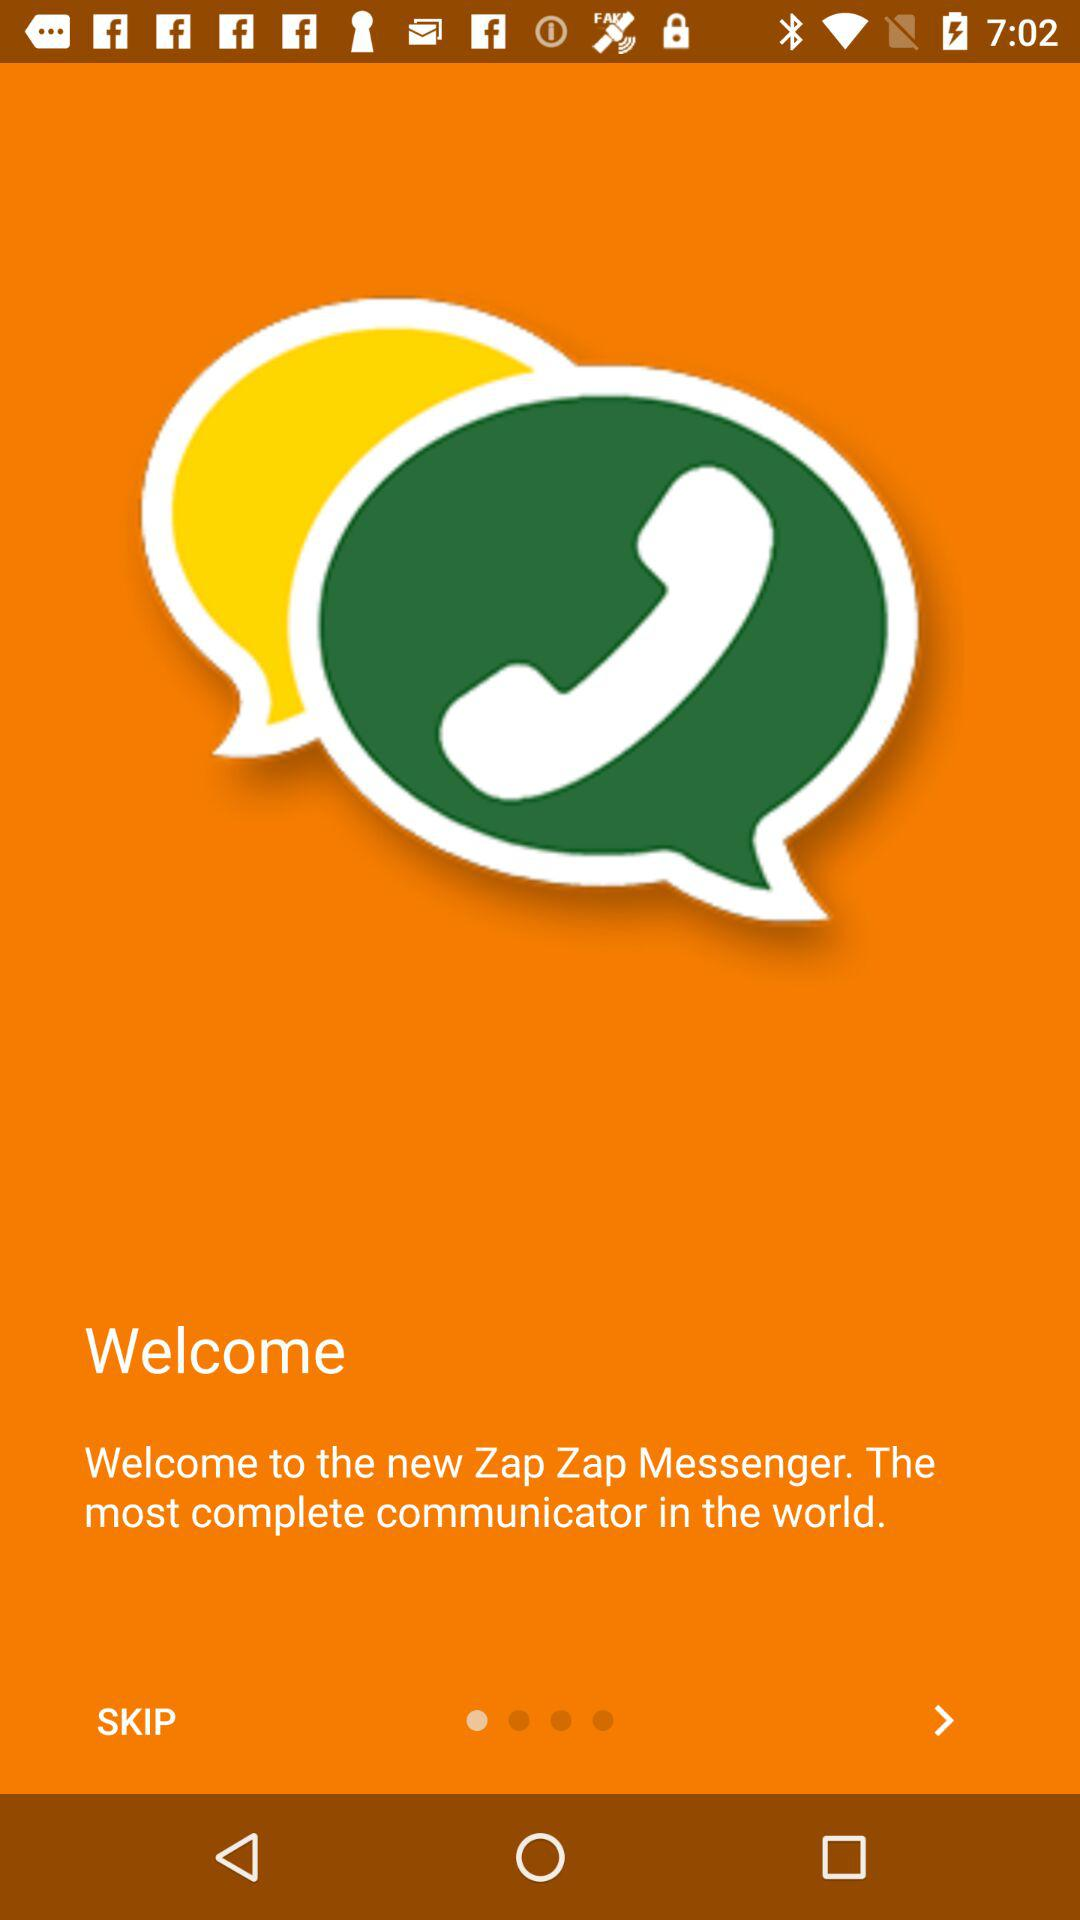What is the app name? The app name is "Zap Zap Messenger". 